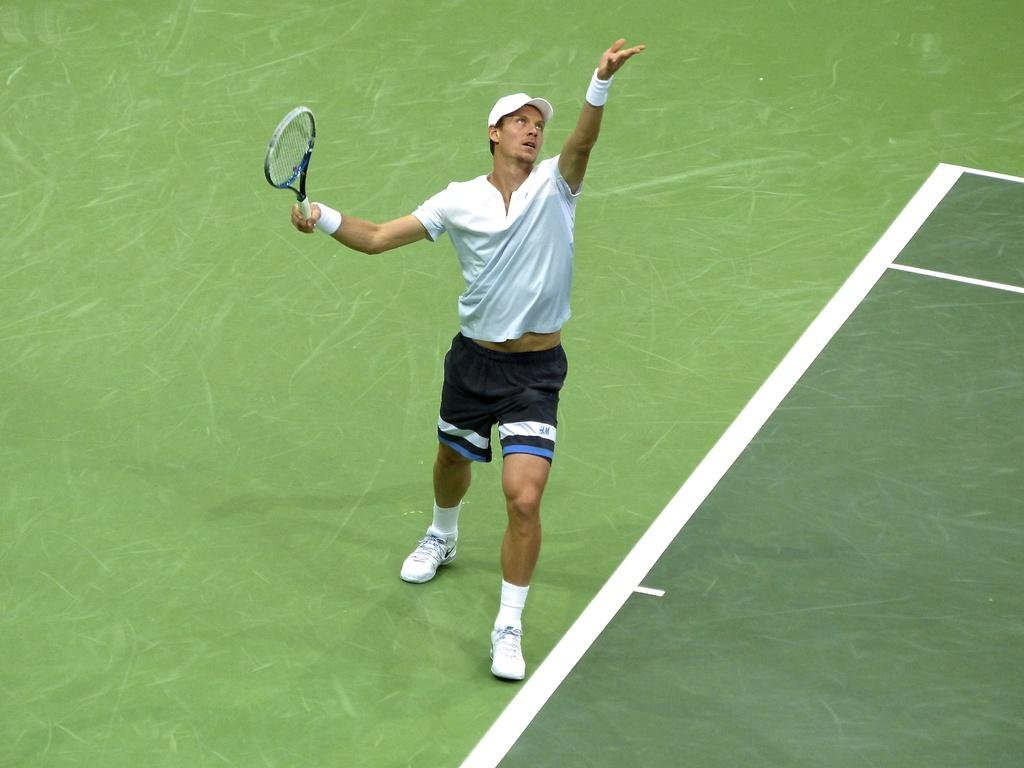Who is present in the image? There is a man in the image. What is the man doing in the image? The man is standing in the image. What object is the man holding in the image? The man is holding a tennis racket in the image. What colors can be seen in the background of the image? The background of the image appears to be green and white in color. What type of weather can be seen in the image? The provided facts do not mention any weather conditions, so it cannot be determined from the image. What type of crops is the farmer harvesting in the image? There is no farmer or crops present in the image; it features a man holding a tennis racket. 